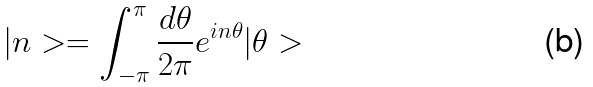<formula> <loc_0><loc_0><loc_500><loc_500>| n > = \int _ { - \pi } ^ { \pi } \frac { d \theta } { 2 \pi } e ^ { i n \theta } | \theta ></formula> 